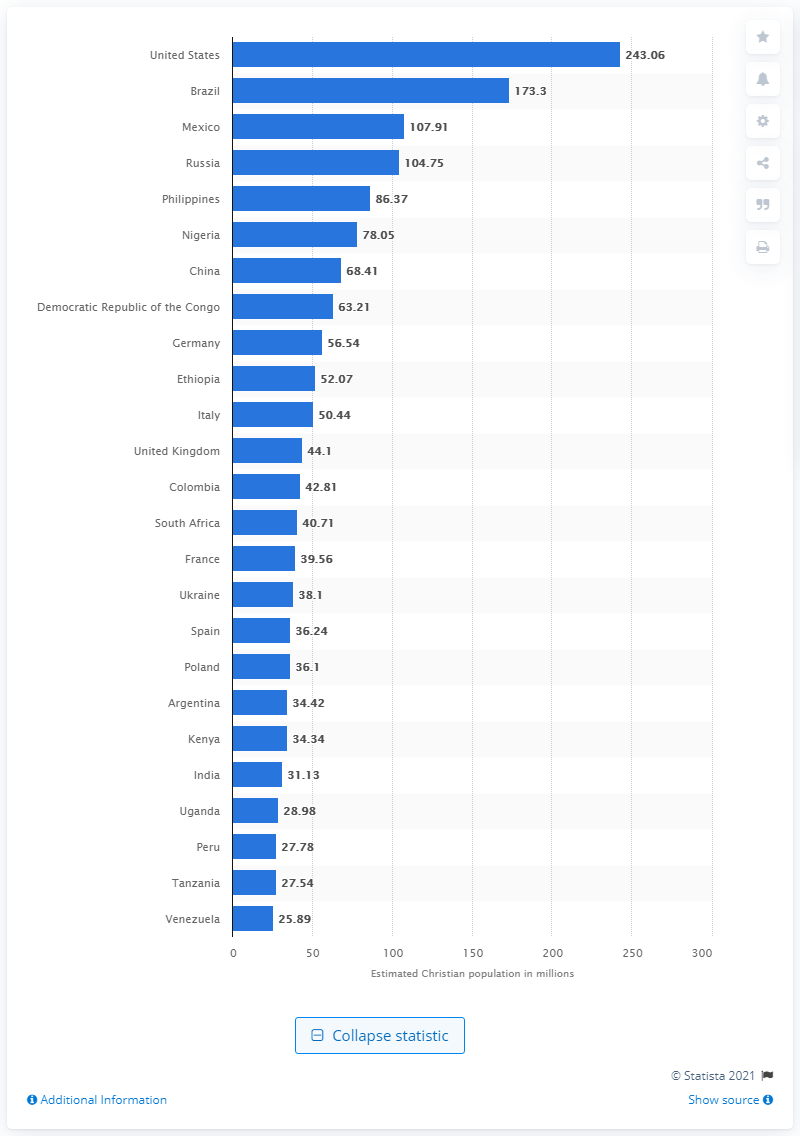Outline some significant characteristics in this image. In 2010, approximately 243.06% of the population of the United States identified as Christians. 